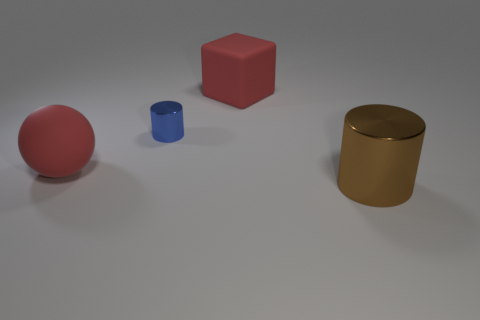Does the big rubber block have the same color as the big cylinder?
Your answer should be very brief. No. Is the color of the tiny object the same as the rubber cube on the right side of the red ball?
Your answer should be very brief. No. What material is the blue thing?
Provide a succinct answer. Metal. What is the color of the shiny cylinder that is left of the brown shiny object?
Your response must be concise. Blue. What number of small shiny objects have the same color as the sphere?
Ensure brevity in your answer.  0. What number of things are both in front of the big red matte block and to the right of the small blue metal object?
Give a very brief answer. 1. There is a brown thing that is the same size as the matte sphere; what shape is it?
Provide a short and direct response. Cylinder. The rubber ball has what size?
Provide a short and direct response. Large. There is a cylinder that is behind the large red matte thing in front of the big rubber thing on the right side of the small blue metal cylinder; what is its material?
Provide a succinct answer. Metal. There is a large cylinder that is made of the same material as the blue object; what color is it?
Keep it short and to the point. Brown. 